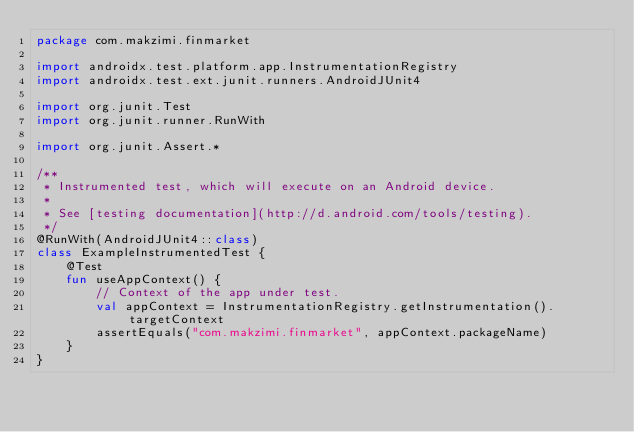Convert code to text. <code><loc_0><loc_0><loc_500><loc_500><_Kotlin_>package com.makzimi.finmarket

import androidx.test.platform.app.InstrumentationRegistry
import androidx.test.ext.junit.runners.AndroidJUnit4

import org.junit.Test
import org.junit.runner.RunWith

import org.junit.Assert.*

/**
 * Instrumented test, which will execute on an Android device.
 *
 * See [testing documentation](http://d.android.com/tools/testing).
 */
@RunWith(AndroidJUnit4::class)
class ExampleInstrumentedTest {
    @Test
    fun useAppContext() {
        // Context of the app under test.
        val appContext = InstrumentationRegistry.getInstrumentation().targetContext
        assertEquals("com.makzimi.finmarket", appContext.packageName)
    }
}
</code> 